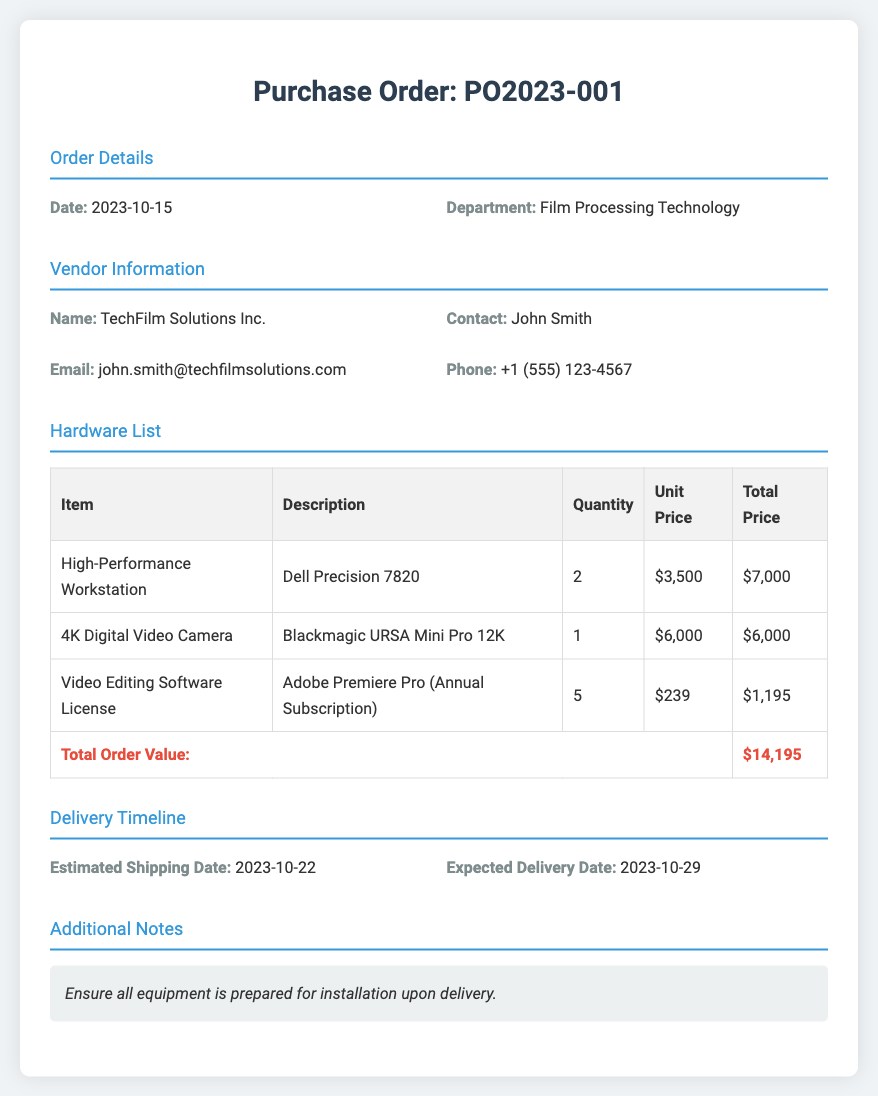What is the purchase order number? The unique identifier for the purchase order is specified in the title of the document.
Answer: PO2023-001 Who is the vendor contact person? The document contains the name of the contact person for the vendor.
Answer: John Smith What is the total order value? The total order value is summarized in the footer of the orders table.
Answer: $14,195 What is the estimated shipping date? The shipping date is explicitly mentioned in the delivery timeline section.
Answer: 2023-10-22 How many video editing software licenses are being purchased? The quantity of software licenses is listed in the hardware list table.
Answer: 5 What type of digital video camera is included in the order? The document specifies the exact model of the camera under the hardware list section.
Answer: Blackmagic URSA Mini Pro 12K What is the expected delivery date? The expected delivery date is provided in the delivery timeline section.
Answer: 2023-10-29 What is the department making the order? The department responsible for the order is mentioned at the beginning of the document.
Answer: Film Processing Technology What is the unit price of the high-performance workstation? The unit price is detailed in the hardware list table.
Answer: $3,500 